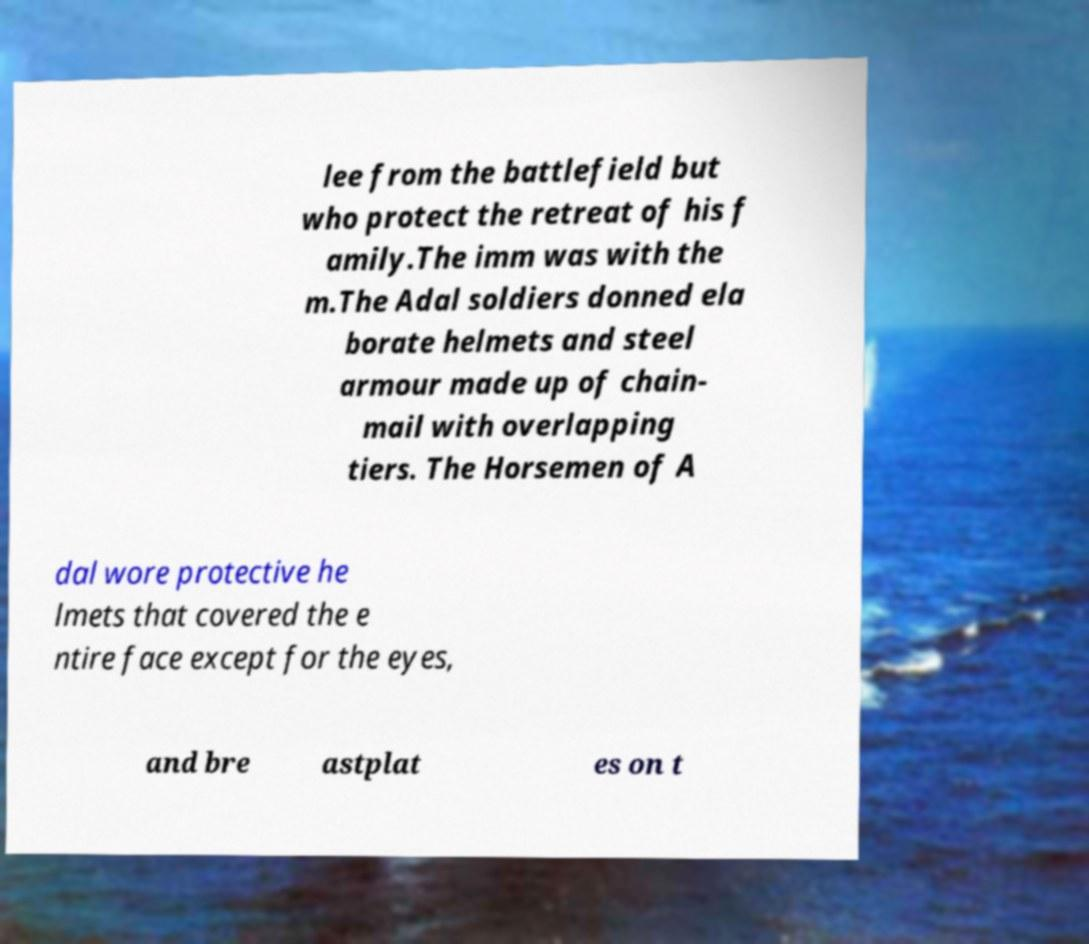Can you read and provide the text displayed in the image?This photo seems to have some interesting text. Can you extract and type it out for me? lee from the battlefield but who protect the retreat of his f amily.The imm was with the m.The Adal soldiers donned ela borate helmets and steel armour made up of chain- mail with overlapping tiers. The Horsemen of A dal wore protective he lmets that covered the e ntire face except for the eyes, and bre astplat es on t 